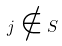Convert formula to latex. <formula><loc_0><loc_0><loc_500><loc_500>j \notin S</formula> 